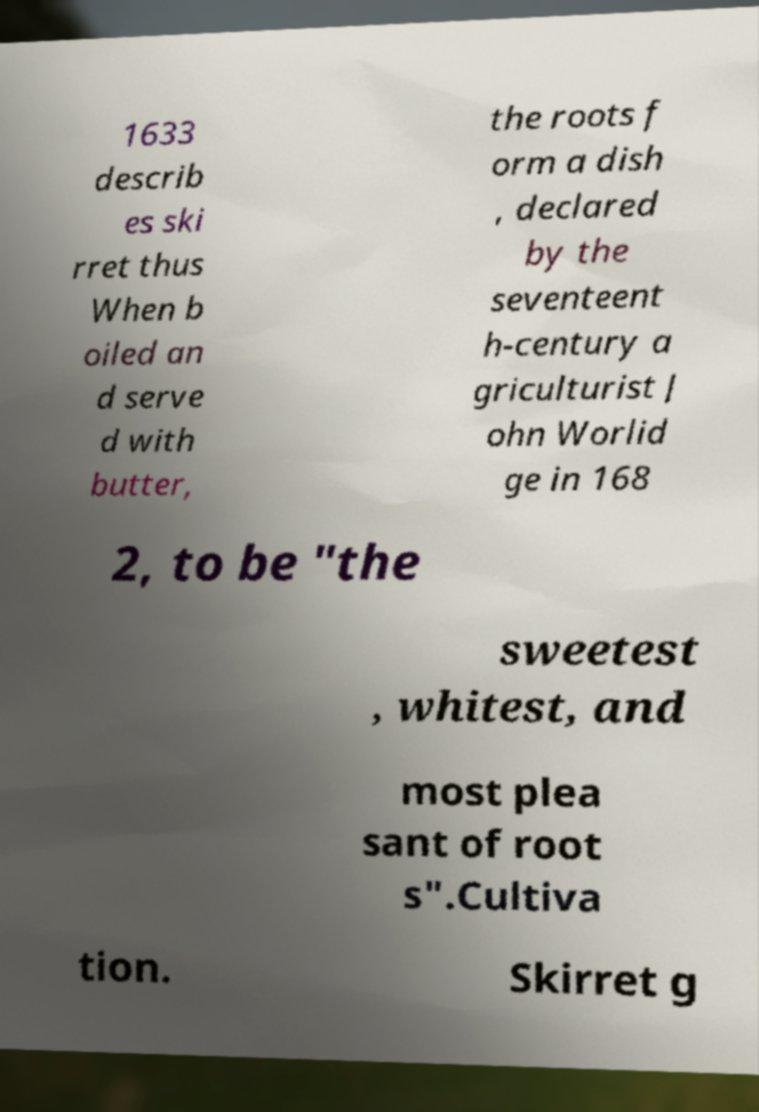Could you extract and type out the text from this image? 1633 describ es ski rret thus When b oiled an d serve d with butter, the roots f orm a dish , declared by the seventeent h-century a griculturist J ohn Worlid ge in 168 2, to be "the sweetest , whitest, and most plea sant of root s".Cultiva tion. Skirret g 